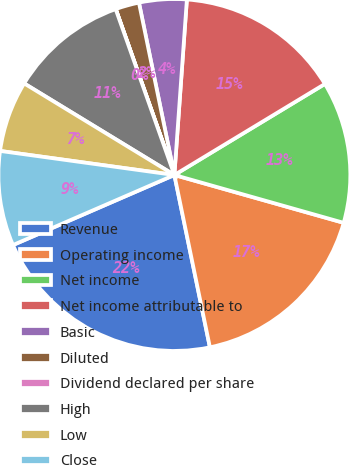Convert chart. <chart><loc_0><loc_0><loc_500><loc_500><pie_chart><fcel>Revenue<fcel>Operating income<fcel>Net income<fcel>Net income attributable to<fcel>Basic<fcel>Diluted<fcel>Dividend declared per share<fcel>High<fcel>Low<fcel>Close<nl><fcel>21.72%<fcel>17.38%<fcel>13.04%<fcel>15.21%<fcel>4.36%<fcel>2.18%<fcel>0.01%<fcel>10.87%<fcel>6.53%<fcel>8.7%<nl></chart> 